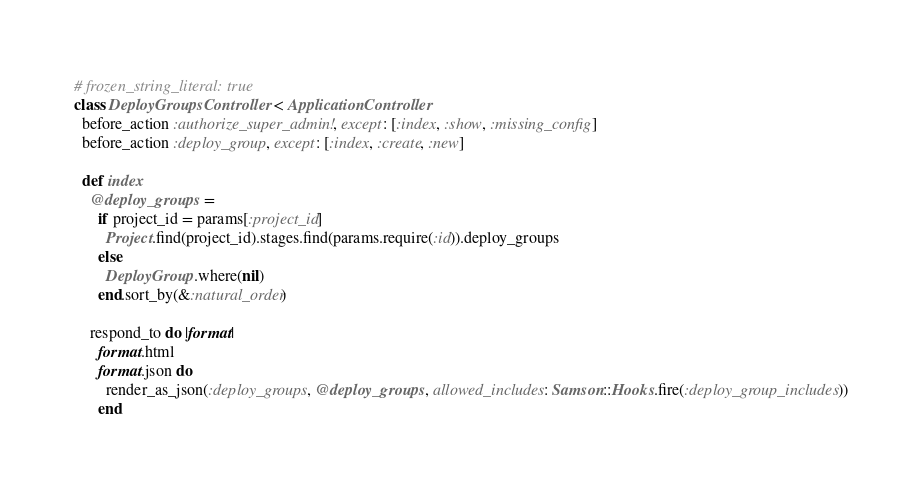<code> <loc_0><loc_0><loc_500><loc_500><_Ruby_># frozen_string_literal: true
class DeployGroupsController < ApplicationController
  before_action :authorize_super_admin!, except: [:index, :show, :missing_config]
  before_action :deploy_group, except: [:index, :create, :new]

  def index
    @deploy_groups =
      if project_id = params[:project_id]
        Project.find(project_id).stages.find(params.require(:id)).deploy_groups
      else
        DeployGroup.where(nil)
      end.sort_by(&:natural_order)

    respond_to do |format|
      format.html
      format.json do
        render_as_json(:deploy_groups, @deploy_groups, allowed_includes: Samson::Hooks.fire(:deploy_group_includes))
      end</code> 